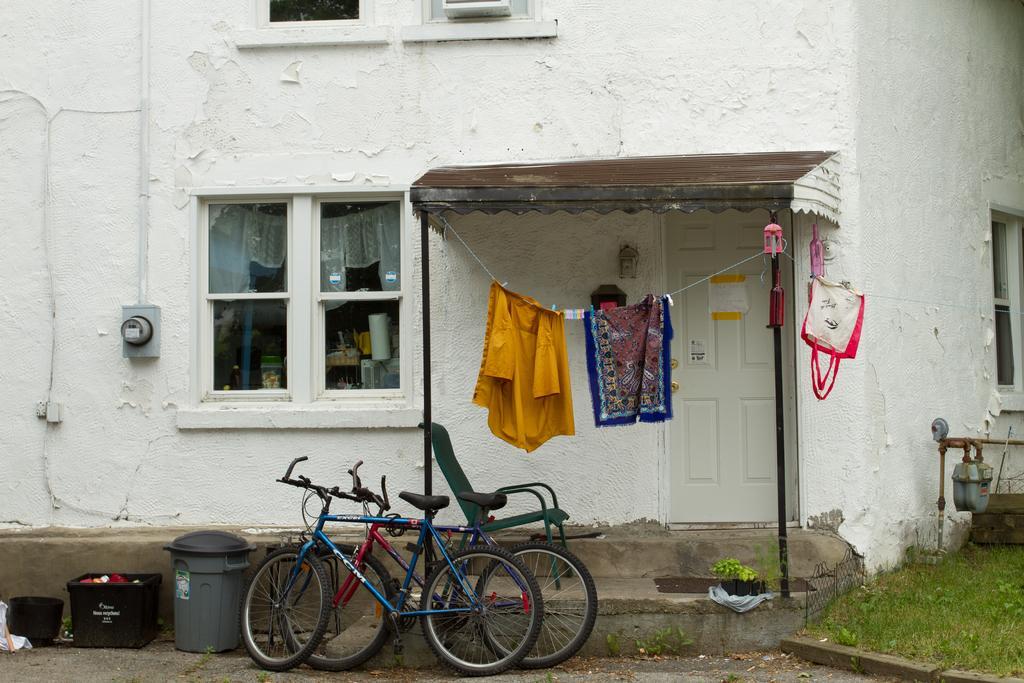Please provide a concise description of this image. In this image in the center there are bicycles and there are bins. In the background there is an empty chair, there are clothes hanging, there is a building which is white in colour. On the right side there is grass on the ground and on the building there are windows and there is a door which is white in colour and there are poles which are black in colour. 